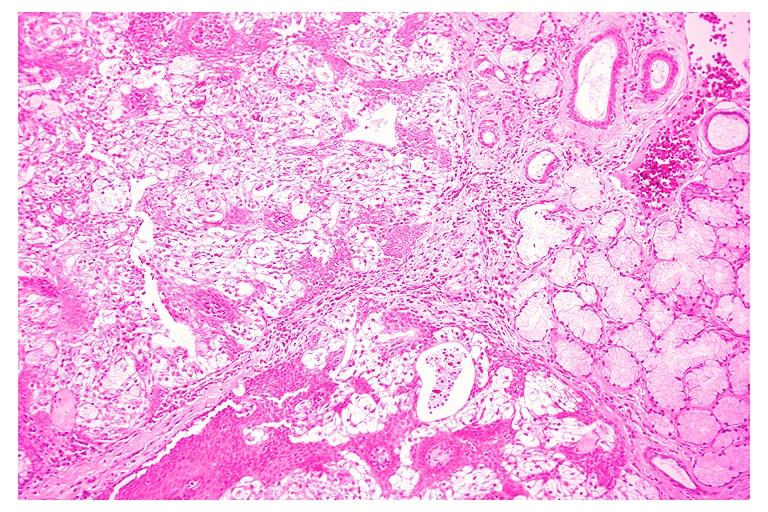s oral present?
Answer the question using a single word or phrase. Yes 